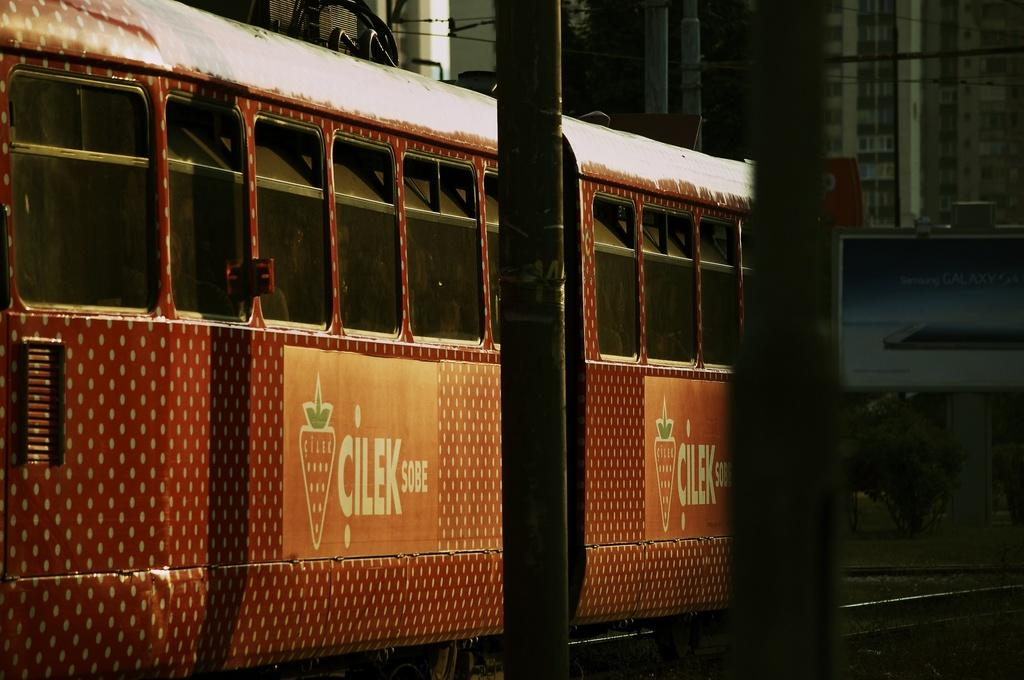What is the main subject of the image? The main subject of the image is a train on the railway track. Are there any other objects or structures near the railway track? Yes, there are two poles near the railway track. What can be seen in the background of the image? In the background, there is a hoarding and some buildings. What type of rhythm can be heard coming from the crate in the image? There is no crate present in the image, so it is not possible to determine what type of rhythm might be heard. 